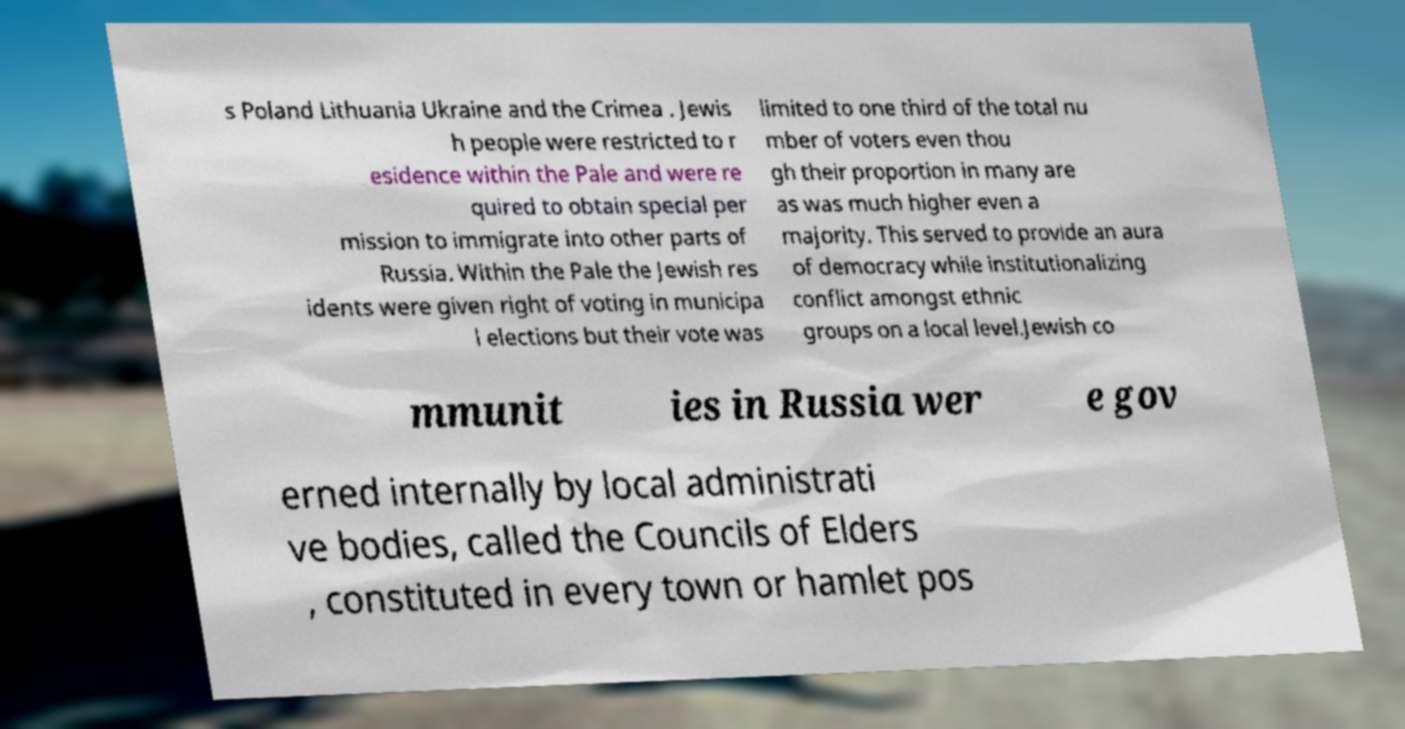What messages or text are displayed in this image? I need them in a readable, typed format. s Poland Lithuania Ukraine and the Crimea . Jewis h people were restricted to r esidence within the Pale and were re quired to obtain special per mission to immigrate into other parts of Russia. Within the Pale the Jewish res idents were given right of voting in municipa l elections but their vote was limited to one third of the total nu mber of voters even thou gh their proportion in many are as was much higher even a majority. This served to provide an aura of democracy while institutionalizing conflict amongst ethnic groups on a local level.Jewish co mmunit ies in Russia wer e gov erned internally by local administrati ve bodies, called the Councils of Elders , constituted in every town or hamlet pos 